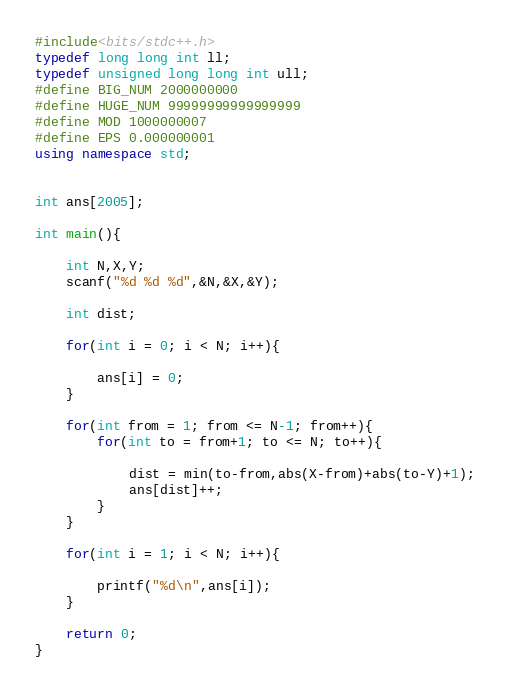Convert code to text. <code><loc_0><loc_0><loc_500><loc_500><_C++_>#include<bits/stdc++.h>
typedef long long int ll;
typedef unsigned long long int ull;
#define BIG_NUM 2000000000
#define HUGE_NUM 99999999999999999
#define MOD 1000000007
#define EPS 0.000000001
using namespace std;


int ans[2005];

int main(){

	int N,X,Y;
	scanf("%d %d %d",&N,&X,&Y);

	int dist;

	for(int i = 0; i < N; i++){

		ans[i] = 0;
	}

	for(int from = 1; from <= N-1; from++){
		for(int to = from+1; to <= N; to++){

			dist = min(to-from,abs(X-from)+abs(to-Y)+1);
			ans[dist]++;
		}
	}

	for(int i = 1; i < N; i++){

		printf("%d\n",ans[i]);
	}

	return 0;
}
</code> 